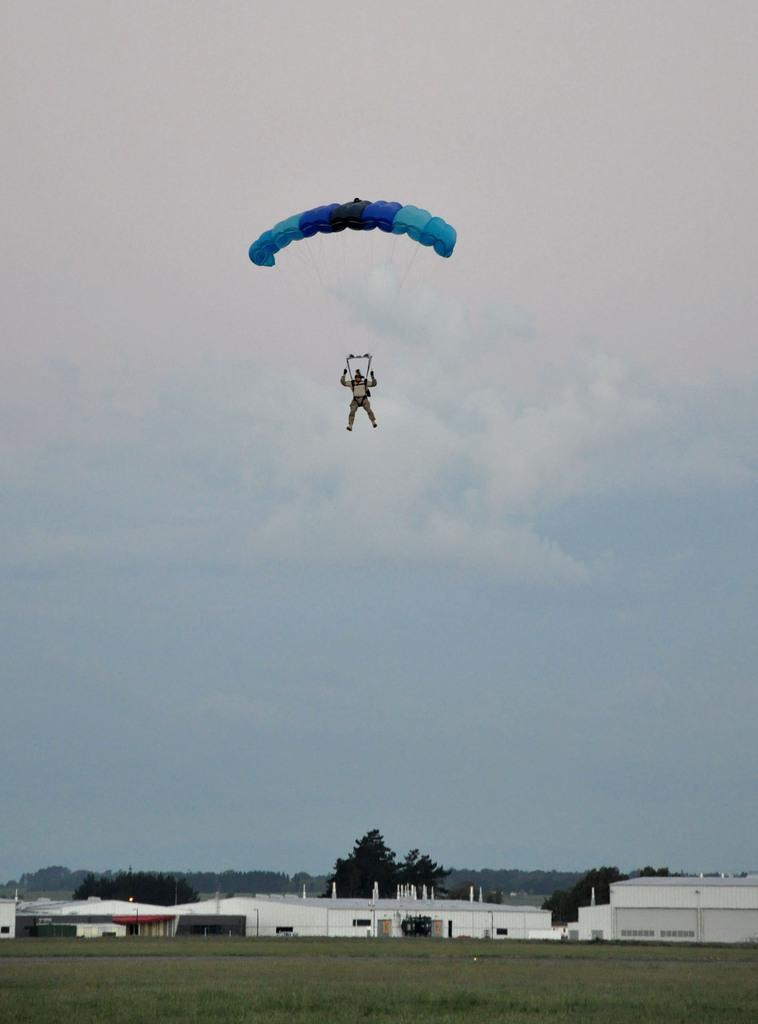How would you summarize this image in a sentence or two? In this picture we can see a person flying with the help of parachute, there are some houses and trees and we can see clouded sky. 